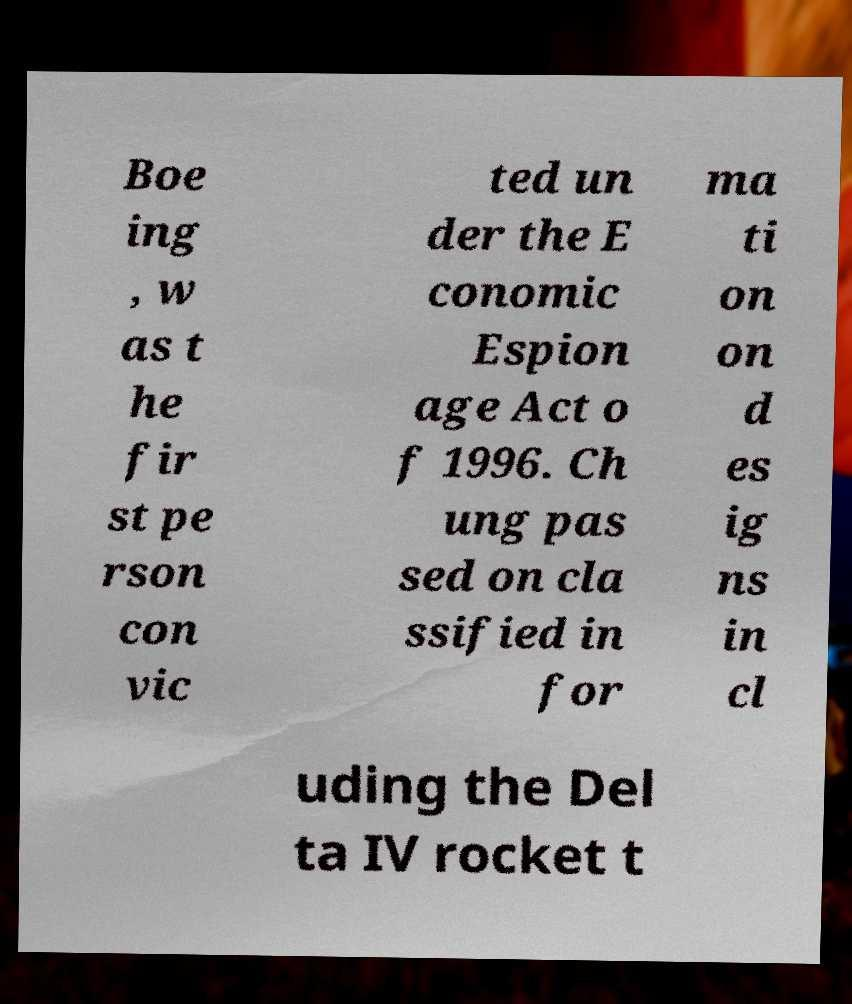For documentation purposes, I need the text within this image transcribed. Could you provide that? Boe ing , w as t he fir st pe rson con vic ted un der the E conomic Espion age Act o f 1996. Ch ung pas sed on cla ssified in for ma ti on on d es ig ns in cl uding the Del ta IV rocket t 